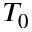Convert formula to latex. <formula><loc_0><loc_0><loc_500><loc_500>T _ { 0 }</formula> 